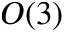<formula> <loc_0><loc_0><loc_500><loc_500>O ( 3 )</formula> 